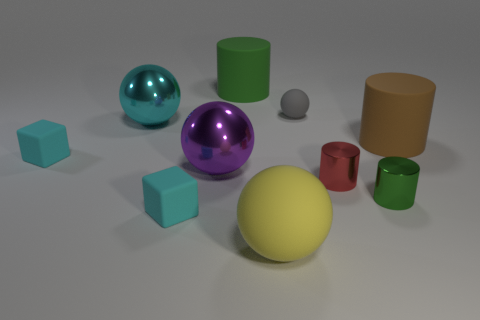Is there any other thing that has the same material as the yellow ball?
Make the answer very short. Yes. Are there fewer rubber blocks to the right of the brown thing than red shiny objects?
Your answer should be very brief. Yes. There is a small cylinder that is on the left side of the green thing that is on the right side of the tiny sphere; what color is it?
Provide a short and direct response. Red. How big is the green cylinder left of the rubber sphere that is to the right of the yellow sphere that is to the right of the large cyan metallic sphere?
Your response must be concise. Large. Are there fewer yellow balls behind the large brown matte cylinder than big green matte cylinders that are right of the tiny red metallic thing?
Provide a short and direct response. No. How many small cylinders are the same material as the tiny red thing?
Offer a very short reply. 1. Are there any cyan metallic spheres to the right of the tiny cyan block in front of the green thing that is in front of the small gray matte object?
Make the answer very short. No. There is a big yellow thing that is the same material as the brown object; what is its shape?
Keep it short and to the point. Sphere. Is the number of cylinders greater than the number of tiny brown metal balls?
Your response must be concise. Yes. Do the purple object and the green thing in front of the gray matte thing have the same shape?
Offer a terse response. No. 